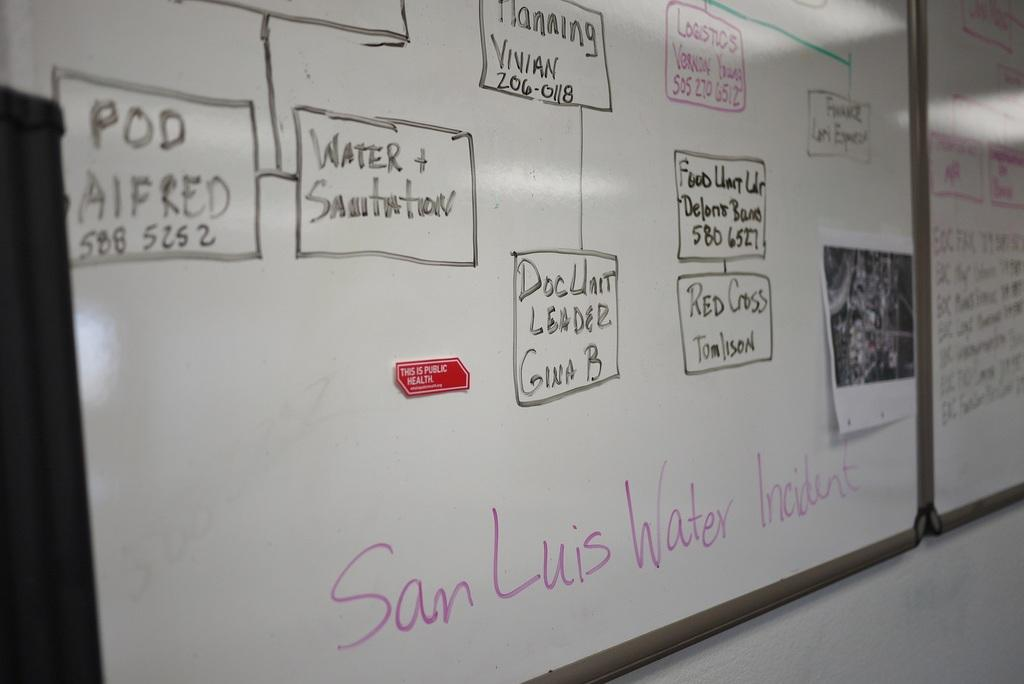<image>
Provide a brief description of the given image. A whiteboard is titled San Luis Water Incident. 